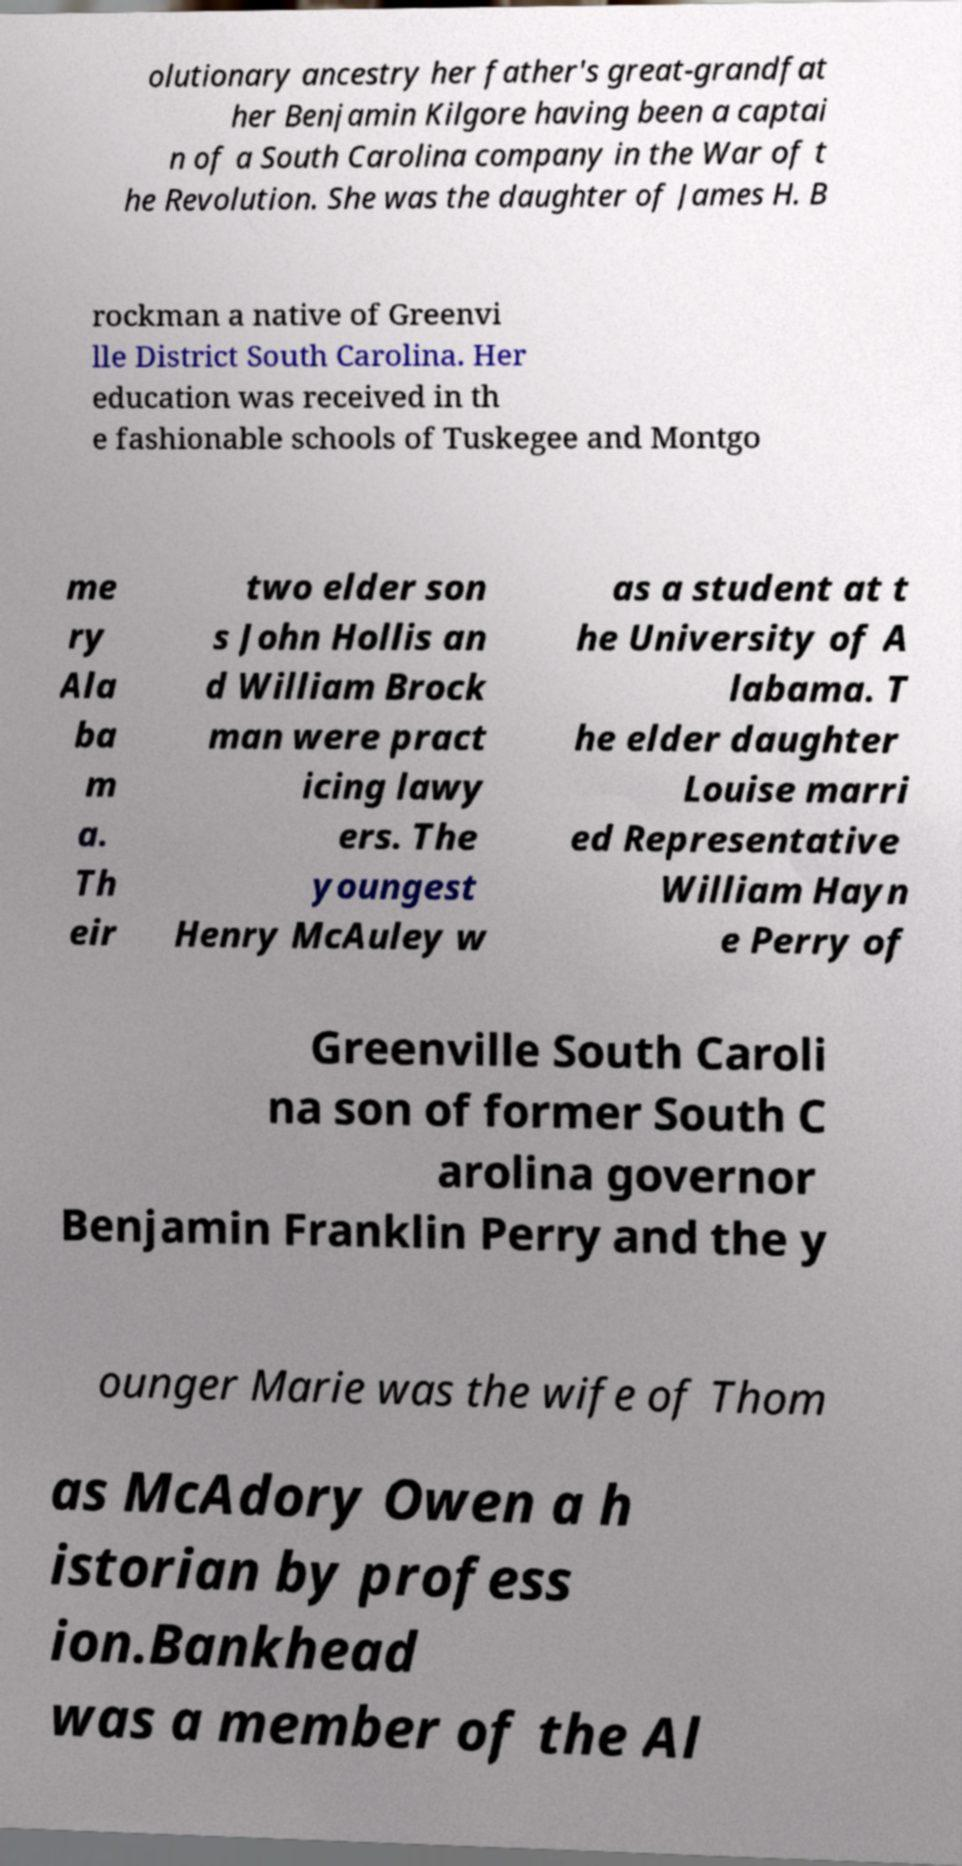Can you accurately transcribe the text from the provided image for me? olutionary ancestry her father's great-grandfat her Benjamin Kilgore having been a captai n of a South Carolina company in the War of t he Revolution. She was the daughter of James H. B rockman a native of Greenvi lle District South Carolina. Her education was received in th e fashionable schools of Tuskegee and Montgo me ry Ala ba m a. Th eir two elder son s John Hollis an d William Brock man were pract icing lawy ers. The youngest Henry McAuley w as a student at t he University of A labama. T he elder daughter Louise marri ed Representative William Hayn e Perry of Greenville South Caroli na son of former South C arolina governor Benjamin Franklin Perry and the y ounger Marie was the wife of Thom as McAdory Owen a h istorian by profess ion.Bankhead was a member of the Al 